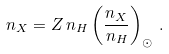<formula> <loc_0><loc_0><loc_500><loc_500>n _ { X } = Z \, n _ { H } \left ( \frac { n _ { X } } { n _ { H } } \right ) _ { \odot } \, .</formula> 